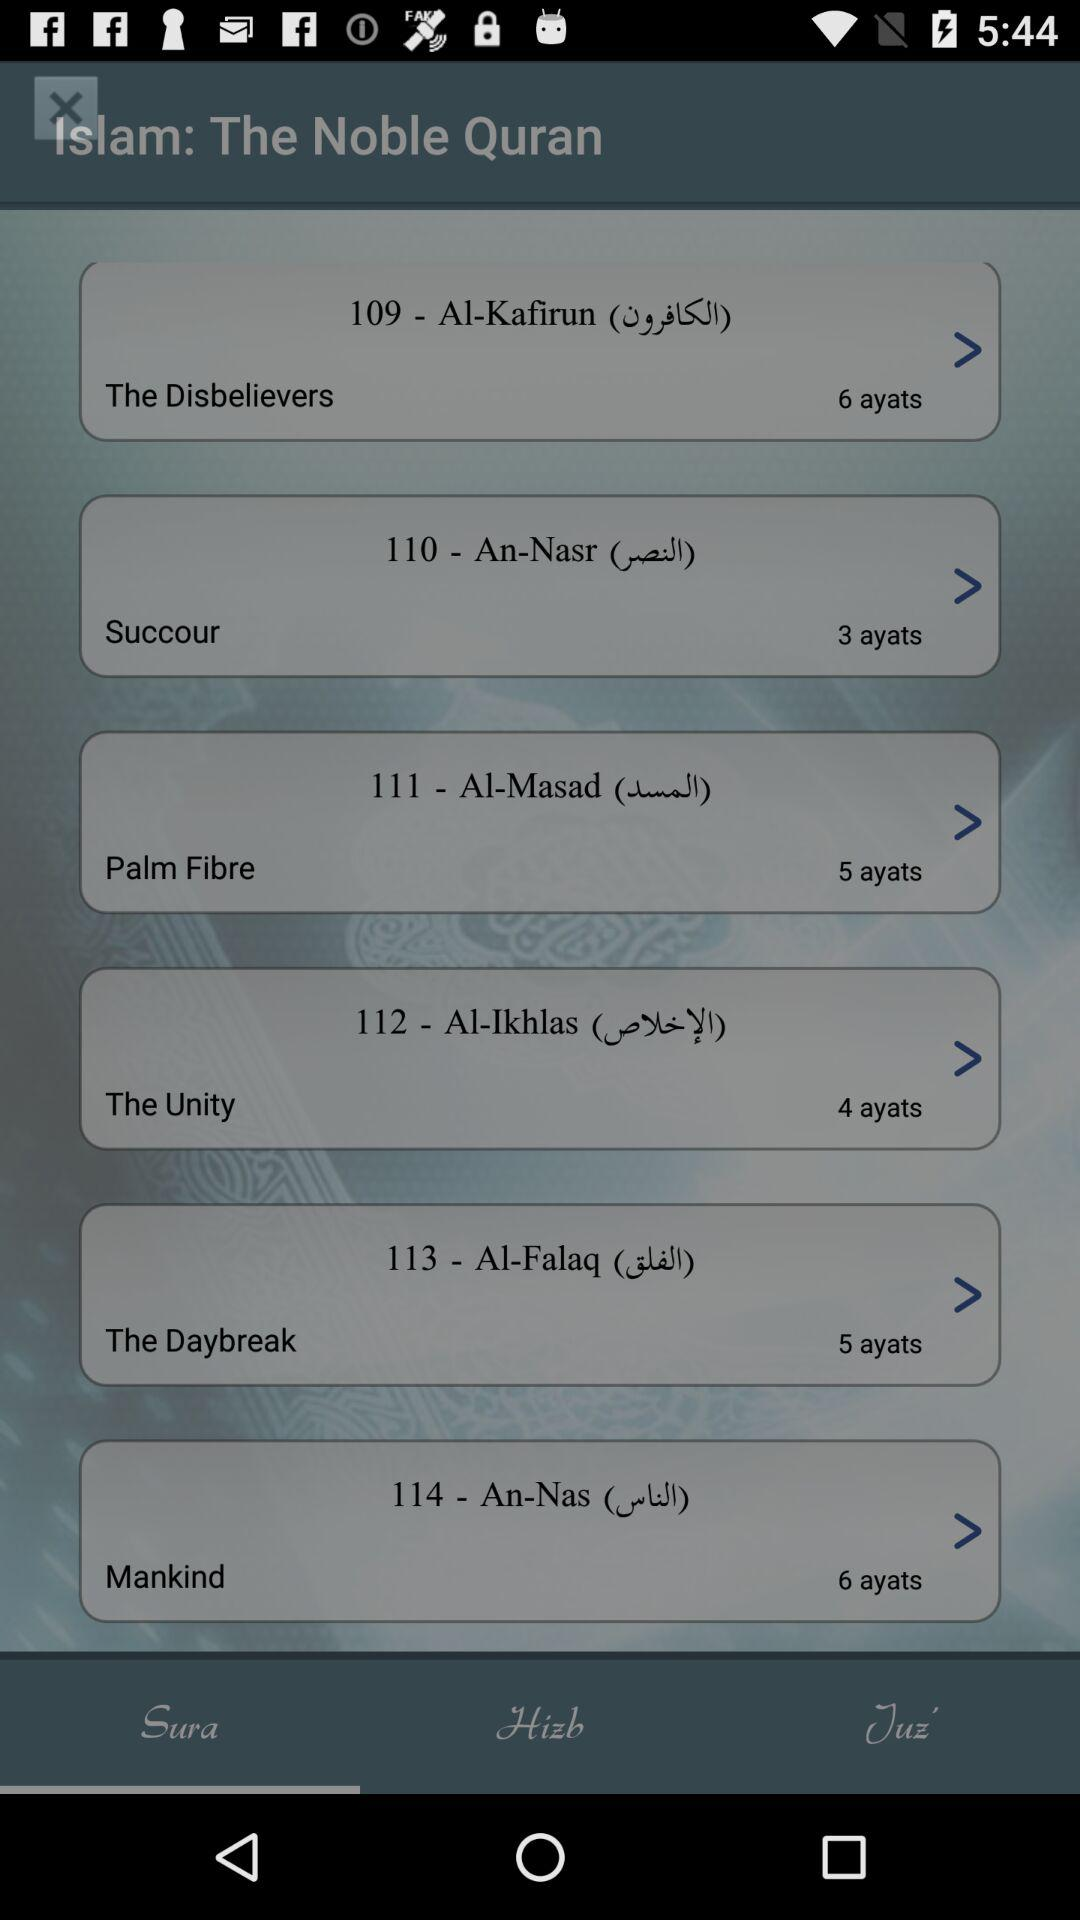How many ayats are there in the last sura?
Answer the question using a single word or phrase. 6 